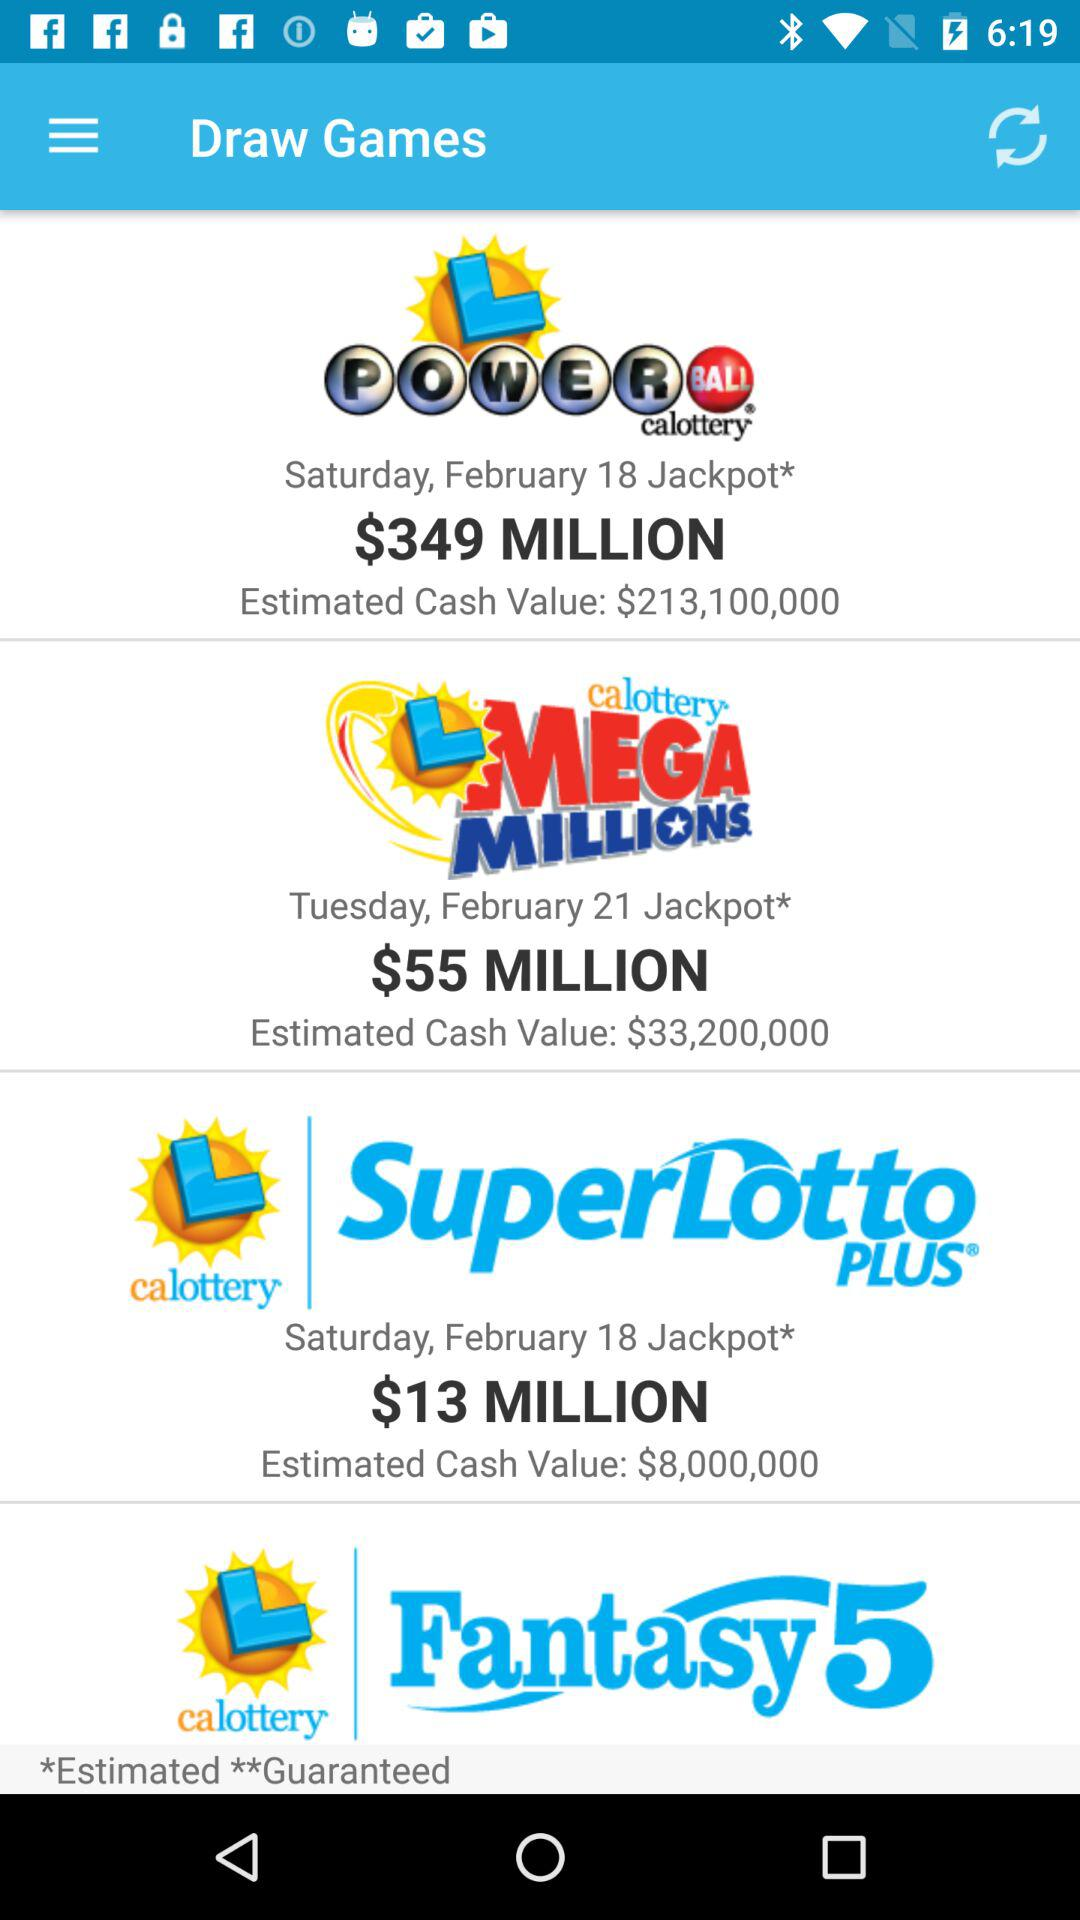What was the estimated cash value of "LMEGA MILLIONS"? The estimated cash value was $33,200,000. 